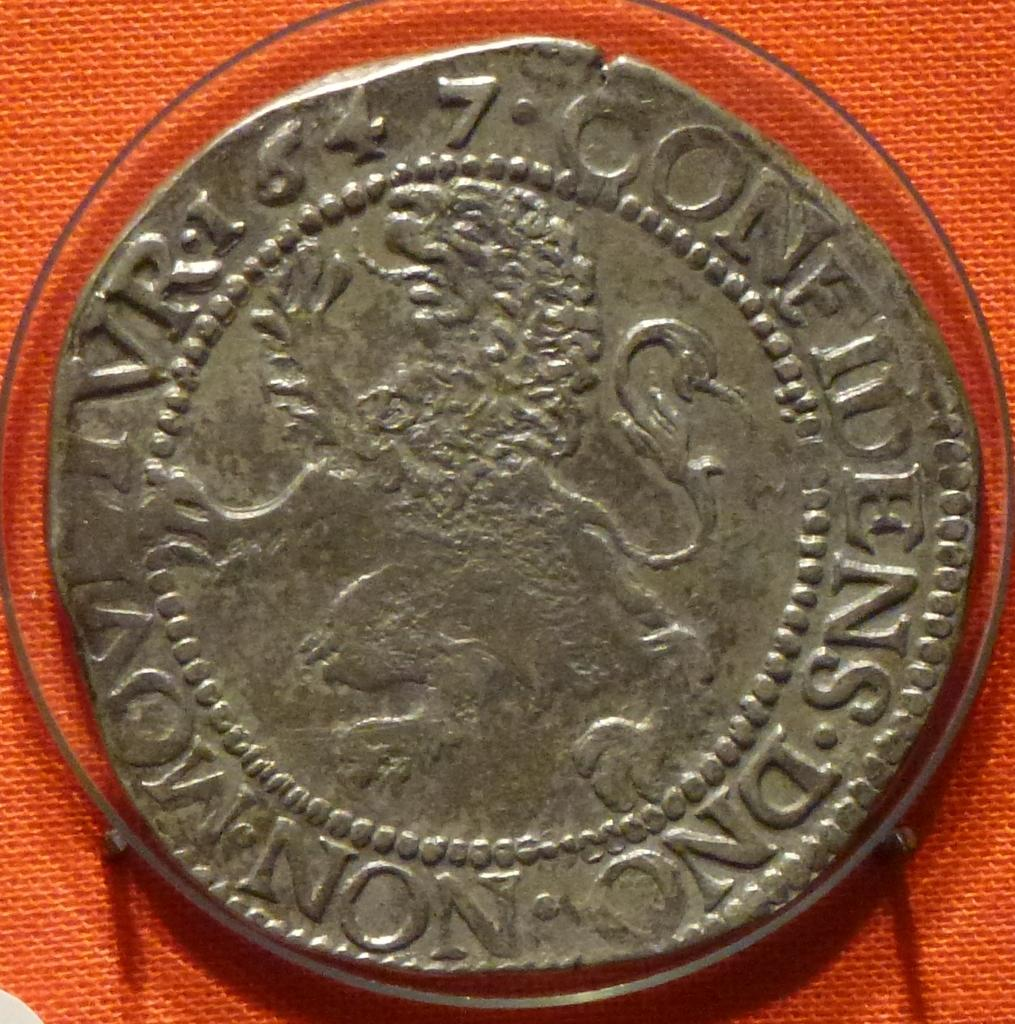Provide a one-sentence caption for the provided image. An old worn out coin with the letters NS DNC written on one side. 